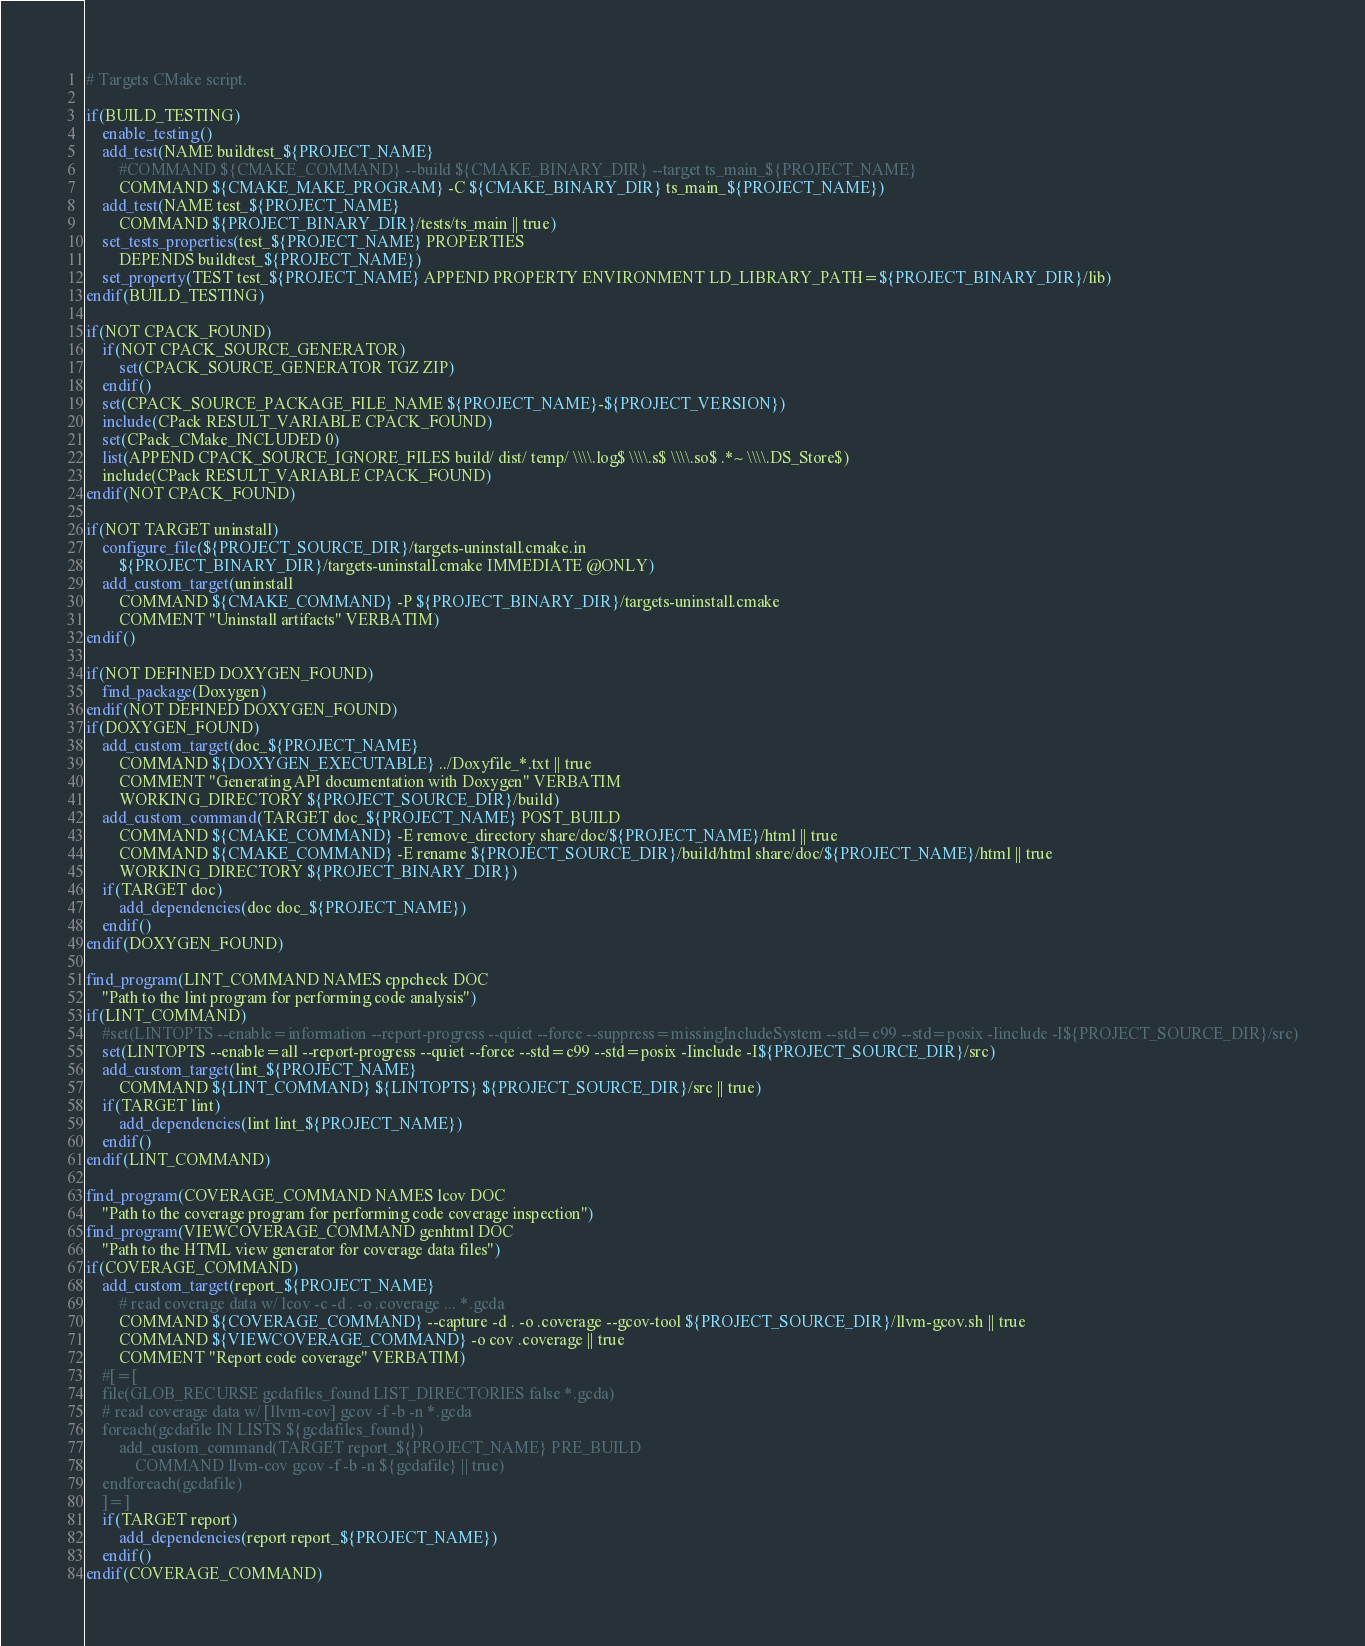<code> <loc_0><loc_0><loc_500><loc_500><_CMake_># Targets CMake script.

if(BUILD_TESTING)
	enable_testing()
	add_test(NAME buildtest_${PROJECT_NAME}
		#COMMAND ${CMAKE_COMMAND} --build ${CMAKE_BINARY_DIR} --target ts_main_${PROJECT_NAME}
		COMMAND ${CMAKE_MAKE_PROGRAM} -C ${CMAKE_BINARY_DIR} ts_main_${PROJECT_NAME})
	add_test(NAME test_${PROJECT_NAME}
		COMMAND ${PROJECT_BINARY_DIR}/tests/ts_main || true)
	set_tests_properties(test_${PROJECT_NAME} PROPERTIES
		DEPENDS buildtest_${PROJECT_NAME})
	set_property(TEST test_${PROJECT_NAME} APPEND PROPERTY ENVIRONMENT LD_LIBRARY_PATH=${PROJECT_BINARY_DIR}/lib)
endif(BUILD_TESTING)

if(NOT CPACK_FOUND)
	if(NOT CPACK_SOURCE_GENERATOR)
		set(CPACK_SOURCE_GENERATOR TGZ ZIP)
	endif()
	set(CPACK_SOURCE_PACKAGE_FILE_NAME ${PROJECT_NAME}-${PROJECT_VERSION})
	include(CPack RESULT_VARIABLE CPACK_FOUND)
	set(CPack_CMake_INCLUDED 0)
	list(APPEND CPACK_SOURCE_IGNORE_FILES build/ dist/ temp/ \\\\.log$ \\\\.s$ \\\\.so$ .*~ \\\\.DS_Store$)
	include(CPack RESULT_VARIABLE CPACK_FOUND)
endif(NOT CPACK_FOUND)

if(NOT TARGET uninstall)
	configure_file(${PROJECT_SOURCE_DIR}/targets-uninstall.cmake.in
		${PROJECT_BINARY_DIR}/targets-uninstall.cmake IMMEDIATE @ONLY)
	add_custom_target(uninstall
		COMMAND ${CMAKE_COMMAND} -P ${PROJECT_BINARY_DIR}/targets-uninstall.cmake
		COMMENT "Uninstall artifacts" VERBATIM)
endif()

if(NOT DEFINED DOXYGEN_FOUND)
	find_package(Doxygen)
endif(NOT DEFINED DOXYGEN_FOUND)
if(DOXYGEN_FOUND)
	add_custom_target(doc_${PROJECT_NAME}
		COMMAND ${DOXYGEN_EXECUTABLE} ../Doxyfile_*.txt || true
		COMMENT "Generating API documentation with Doxygen" VERBATIM
		WORKING_DIRECTORY ${PROJECT_SOURCE_DIR}/build)
	add_custom_command(TARGET doc_${PROJECT_NAME} POST_BUILD
		COMMAND ${CMAKE_COMMAND} -E remove_directory share/doc/${PROJECT_NAME}/html || true
		COMMAND ${CMAKE_COMMAND} -E rename ${PROJECT_SOURCE_DIR}/build/html share/doc/${PROJECT_NAME}/html || true
		WORKING_DIRECTORY ${PROJECT_BINARY_DIR})
	if(TARGET doc)
		add_dependencies(doc doc_${PROJECT_NAME})
	endif()
endif(DOXYGEN_FOUND)

find_program(LINT_COMMAND NAMES cppcheck DOC
	"Path to the lint program for performing code analysis")
if(LINT_COMMAND)
	#set(LINTOPTS --enable=information --report-progress --quiet --force --suppress=missingIncludeSystem --std=c99 --std=posix -Iinclude -I${PROJECT_SOURCE_DIR}/src)
	set(LINTOPTS --enable=all --report-progress --quiet --force --std=c99 --std=posix -Iinclude -I${PROJECT_SOURCE_DIR}/src)
	add_custom_target(lint_${PROJECT_NAME}
		COMMAND ${LINT_COMMAND} ${LINTOPTS} ${PROJECT_SOURCE_DIR}/src || true)
	if(TARGET lint)
		add_dependencies(lint lint_${PROJECT_NAME})
	endif()
endif(LINT_COMMAND)

find_program(COVERAGE_COMMAND NAMES lcov DOC
	"Path to the coverage program for performing code coverage inspection")
find_program(VIEWCOVERAGE_COMMAND genhtml DOC
	"Path to the HTML view generator for coverage data files")
if(COVERAGE_COMMAND)
	add_custom_target(report_${PROJECT_NAME}
		# read coverage data w/ lcov -c -d . -o .coverage ... *.gcda
		COMMAND ${COVERAGE_COMMAND} --capture -d . -o .coverage --gcov-tool ${PROJECT_SOURCE_DIR}/llvm-gcov.sh || true
		COMMAND ${VIEWCOVERAGE_COMMAND} -o cov .coverage || true
		COMMENT "Report code coverage" VERBATIM)
	#[=[
	file(GLOB_RECURSE gcdafiles_found LIST_DIRECTORIES false *.gcda)
	# read coverage data w/ [llvm-cov] gcov -f -b -n *.gcda
	foreach(gcdafile IN LISTS ${gcdafiles_found})
		add_custom_command(TARGET report_${PROJECT_NAME} PRE_BUILD
			COMMAND llvm-cov gcov -f -b -n ${gcdafile} || true)
	endforeach(gcdafile)
	]=]
	if(TARGET report)
		add_dependencies(report report_${PROJECT_NAME})
	endif()
endif(COVERAGE_COMMAND)
</code> 